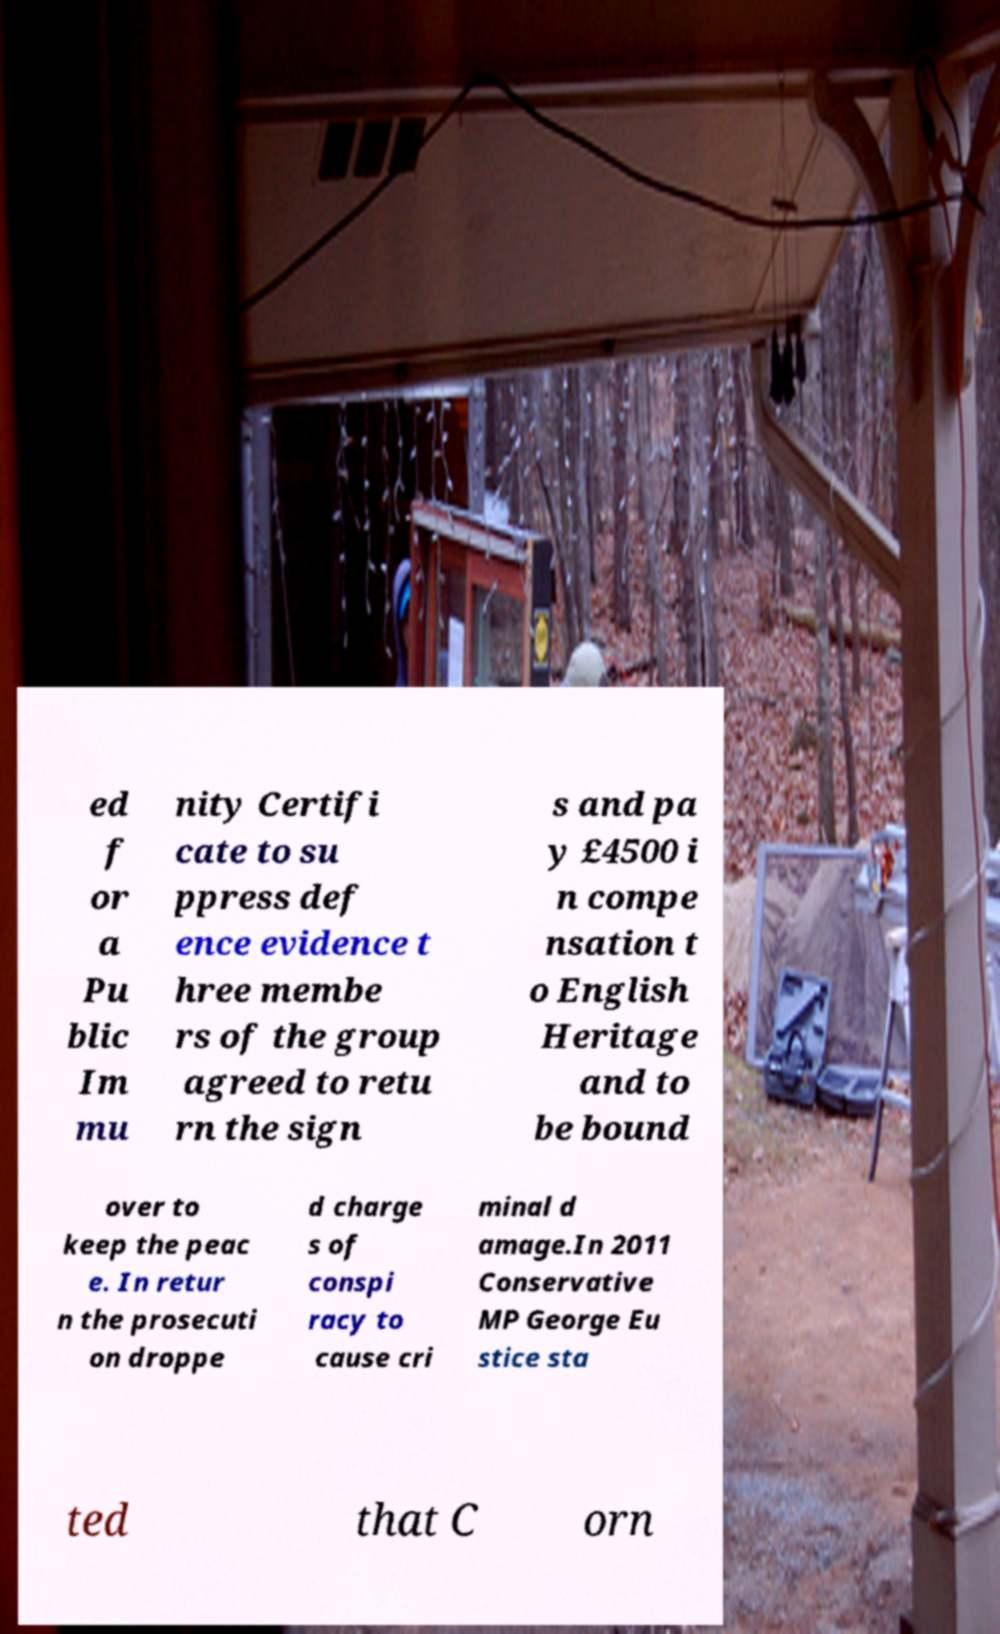Could you extract and type out the text from this image? ed f or a Pu blic Im mu nity Certifi cate to su ppress def ence evidence t hree membe rs of the group agreed to retu rn the sign s and pa y £4500 i n compe nsation t o English Heritage and to be bound over to keep the peac e. In retur n the prosecuti on droppe d charge s of conspi racy to cause cri minal d amage.In 2011 Conservative MP George Eu stice sta ted that C orn 